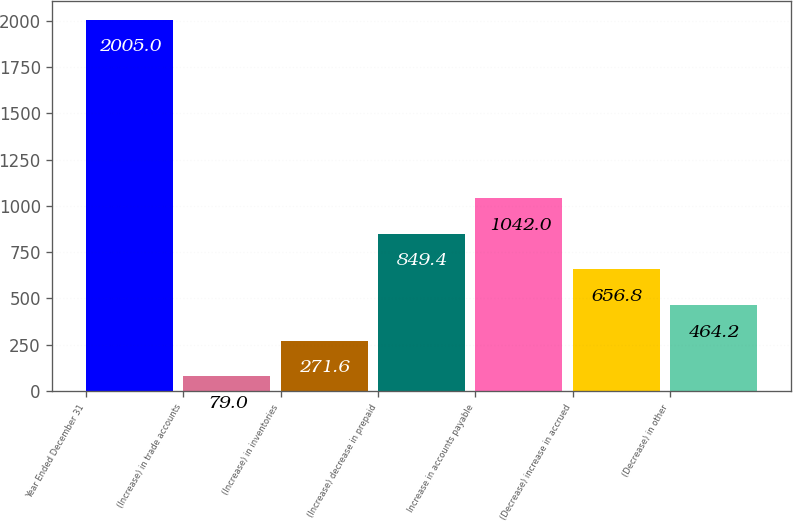<chart> <loc_0><loc_0><loc_500><loc_500><bar_chart><fcel>Year Ended December 31<fcel>(Increase) in trade accounts<fcel>(Increase) in inventories<fcel>(Increase) decrease in prepaid<fcel>Increase in accounts payable<fcel>(Decrease) increase in accrued<fcel>(Decrease) in other<nl><fcel>2005<fcel>79<fcel>271.6<fcel>849.4<fcel>1042<fcel>656.8<fcel>464.2<nl></chart> 